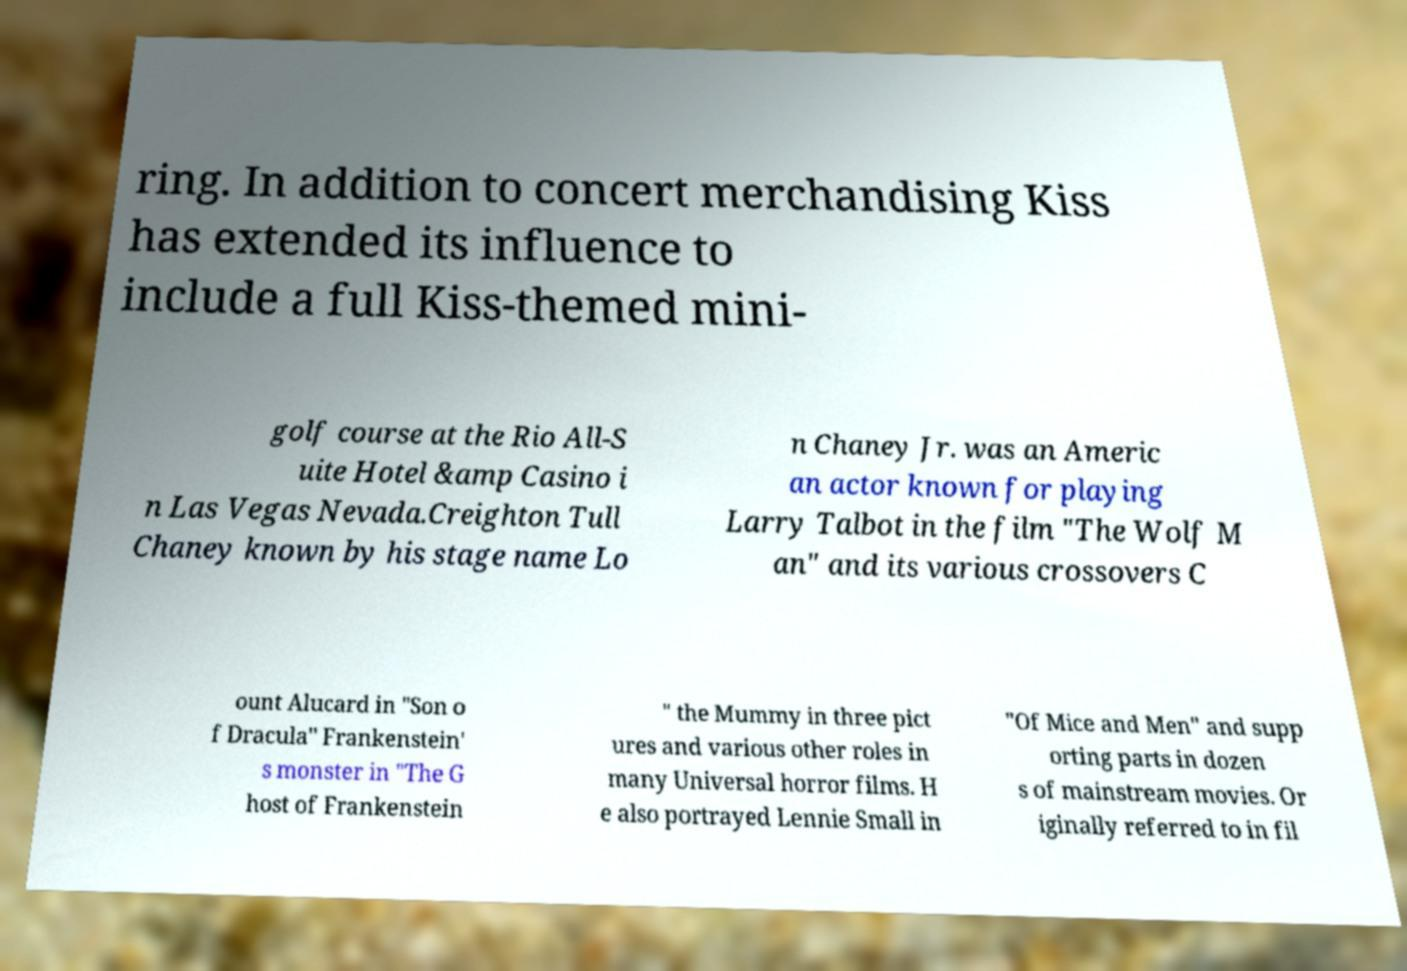Please read and relay the text visible in this image. What does it say? ring. In addition to concert merchandising Kiss has extended its influence to include a full Kiss-themed mini- golf course at the Rio All-S uite Hotel &amp Casino i n Las Vegas Nevada.Creighton Tull Chaney known by his stage name Lo n Chaney Jr. was an Americ an actor known for playing Larry Talbot in the film "The Wolf M an" and its various crossovers C ount Alucard in "Son o f Dracula" Frankenstein' s monster in "The G host of Frankenstein " the Mummy in three pict ures and various other roles in many Universal horror films. H e also portrayed Lennie Small in "Of Mice and Men" and supp orting parts in dozen s of mainstream movies. Or iginally referred to in fil 